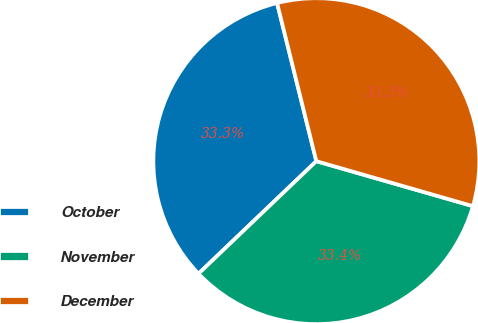Convert chart to OTSL. <chart><loc_0><loc_0><loc_500><loc_500><pie_chart><fcel>October<fcel>November<fcel>December<nl><fcel>33.26%<fcel>33.41%<fcel>33.32%<nl></chart> 